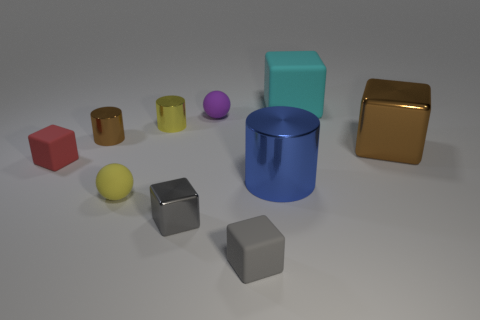Subtract all brown cubes. How many cubes are left? 4 Subtract all red cubes. How many cubes are left? 4 Subtract all yellow cubes. Subtract all cyan spheres. How many cubes are left? 5 Subtract all spheres. How many objects are left? 8 Add 8 tiny purple objects. How many tiny purple objects exist? 9 Subtract 0 gray cylinders. How many objects are left? 10 Subtract all tiny gray objects. Subtract all small red cubes. How many objects are left? 7 Add 2 tiny yellow rubber spheres. How many tiny yellow rubber spheres are left? 3 